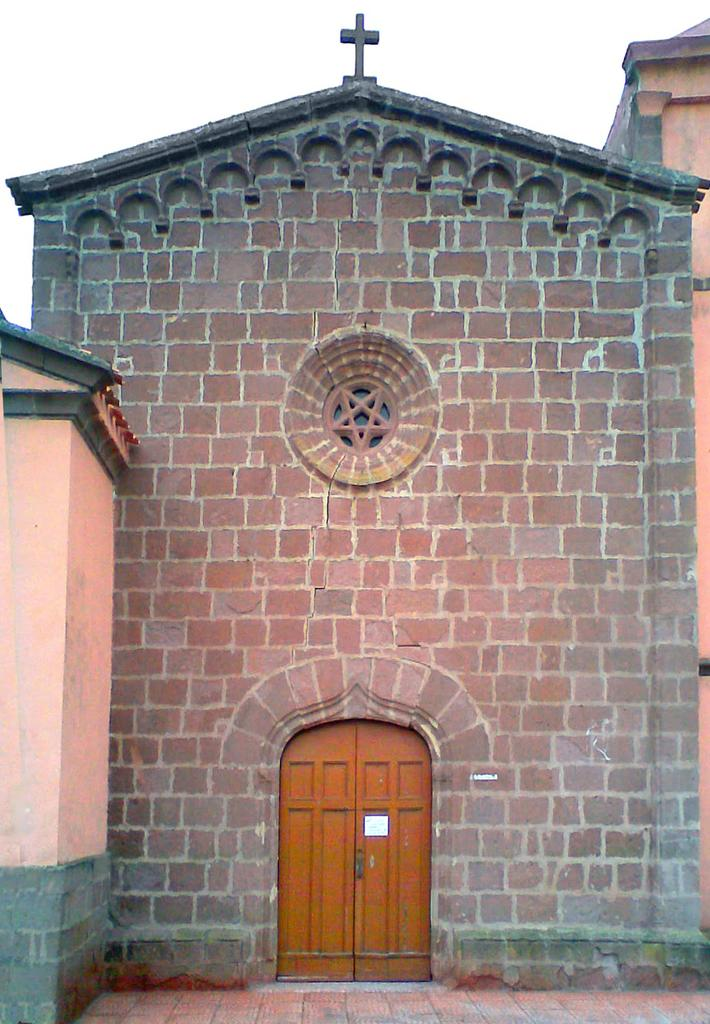What type of building is the main subject of the image? There is a church in the image. Can you describe any specific features of the church? The provided facts do not mention any specific features of the church. Is there any other notable element in the image besides the church? The provided facts do not mention any other notable elements in the image. What type of bead is being used to create steam in the image? There is no bead or steam present in the image; it features a church. 